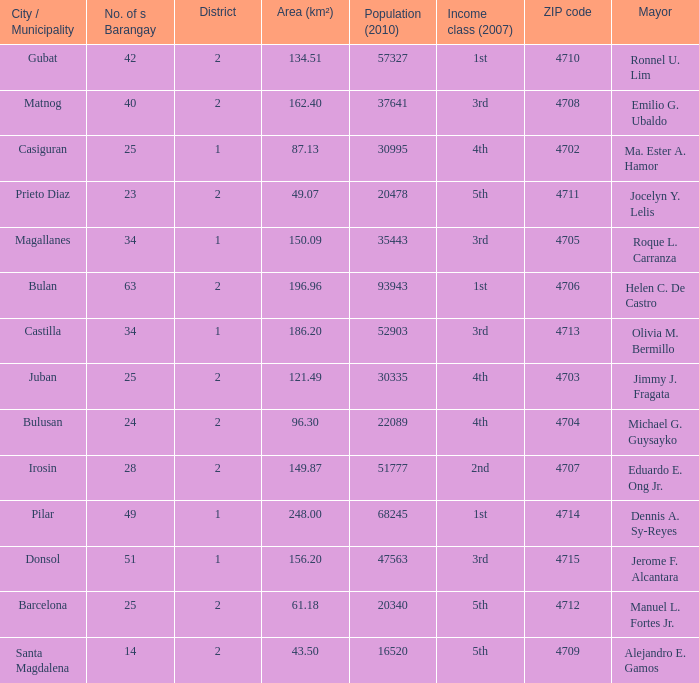What is the total quantity of populace (2010) where location (km²) is 134.51 1.0. 